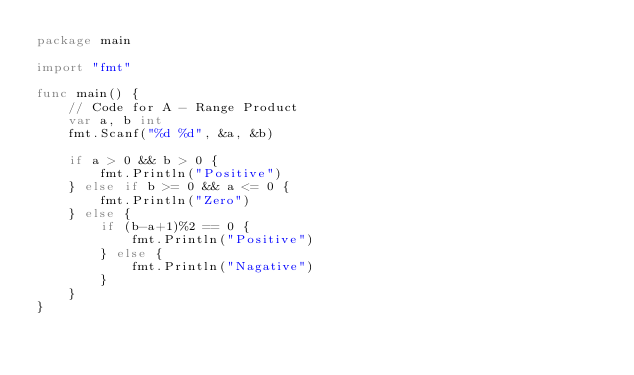<code> <loc_0><loc_0><loc_500><loc_500><_Go_>package main

import "fmt"

func main() {
	// Code for A - Range Product
	var a, b int
	fmt.Scanf("%d %d", &a, &b)

	if a > 0 && b > 0 {
		fmt.Println("Positive")
	} else if b >= 0 && a <= 0 {
		fmt.Println("Zero")
	} else {
		if (b-a+1)%2 == 0 {
			fmt.Println("Positive")
		} else {
			fmt.Println("Nagative")
		}
	}
}
</code> 